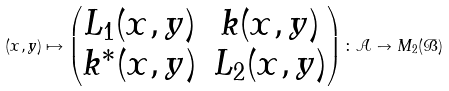<formula> <loc_0><loc_0><loc_500><loc_500>( x , y ) \mapsto \begin{pmatrix} L _ { 1 } ( x , y ) & k ( x , y ) \\ k ^ { \ast } ( x , y ) & L _ { 2 } ( x , y ) \end{pmatrix} \colon \mathcal { A } \to M _ { 2 } ( \mathcal { B } )</formula> 